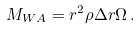Convert formula to latex. <formula><loc_0><loc_0><loc_500><loc_500>M _ { W A } = r ^ { 2 } { \rho } { \Delta } { r } \Omega \, .</formula> 